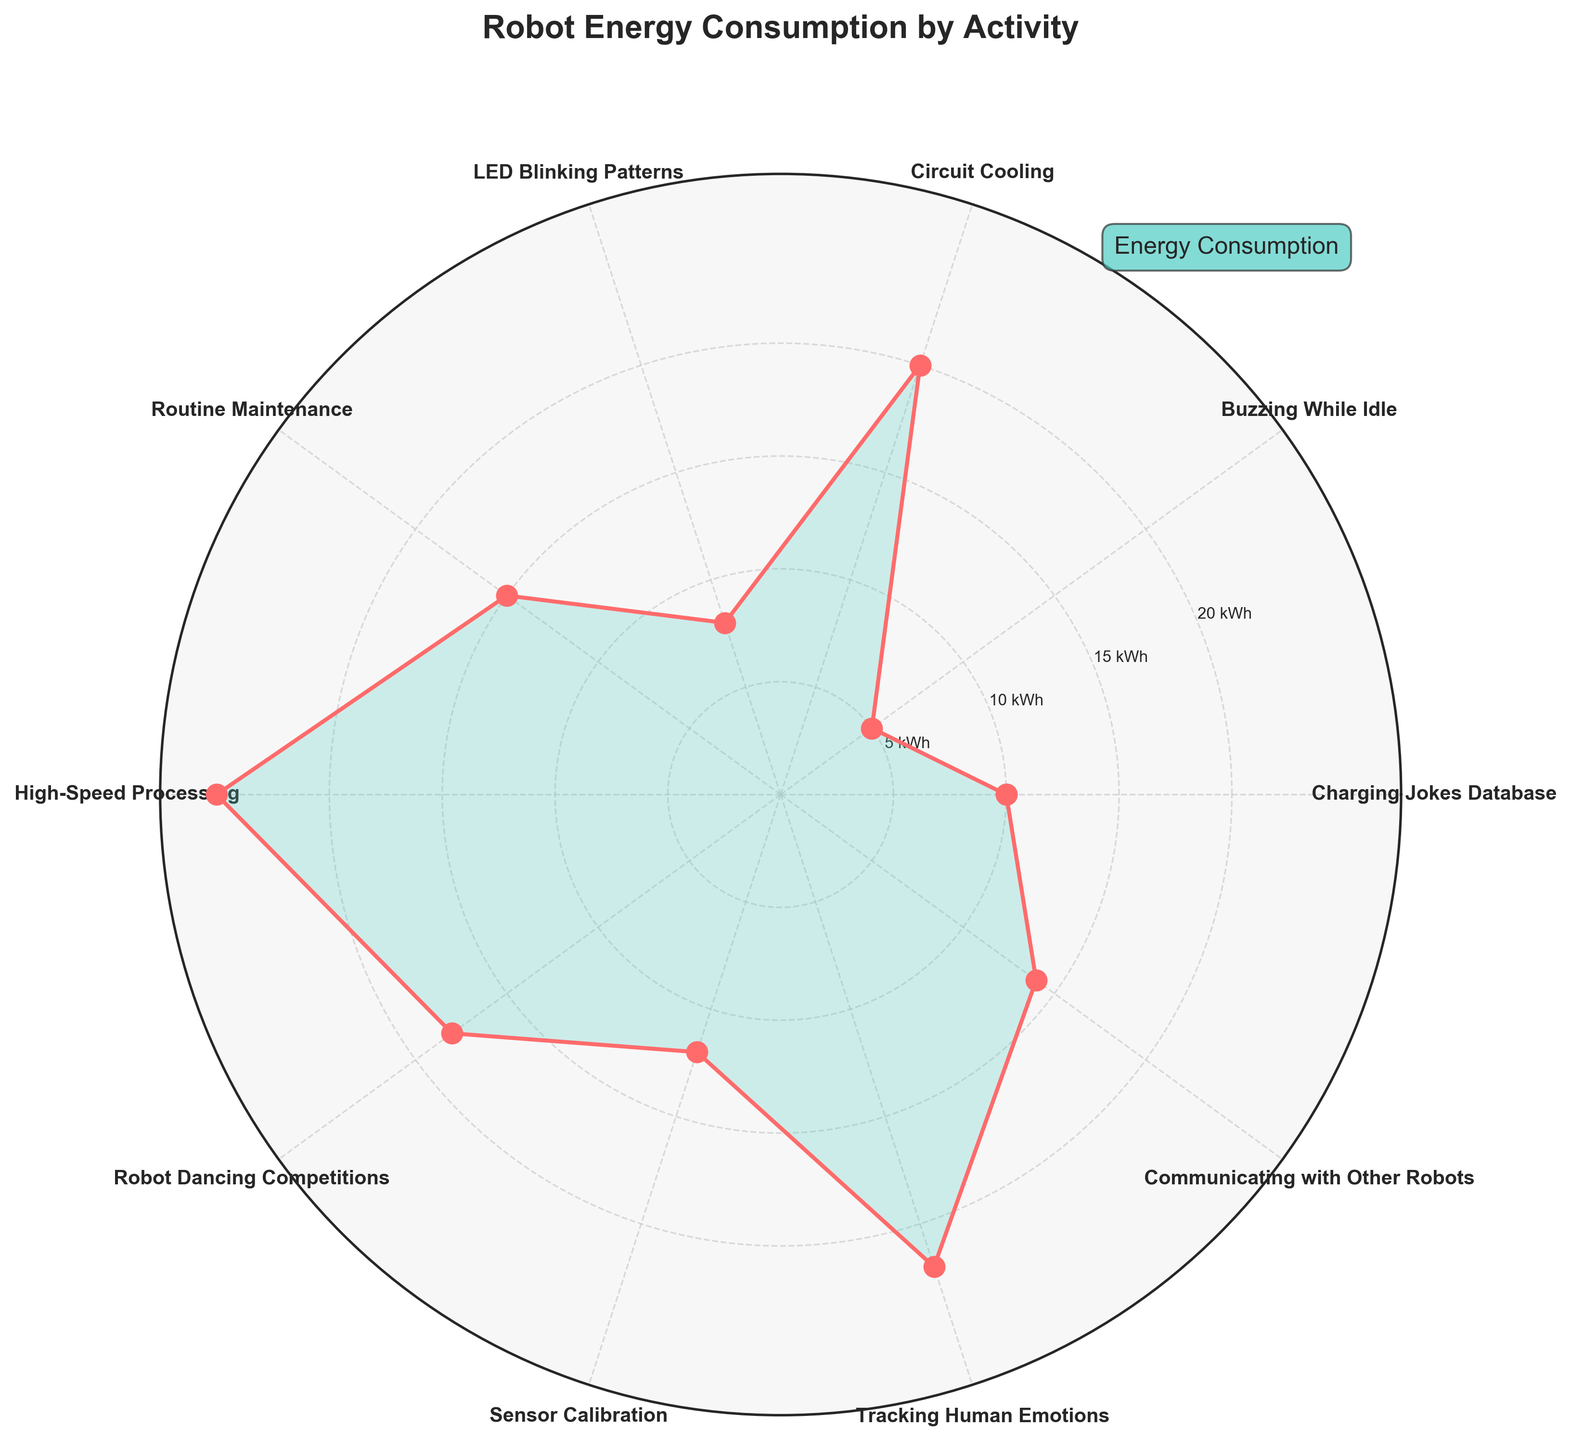What's the title of the figure? The title is positioned at the top of the plot, styled in a large, bold font for emphasis. It clearly indicates the main subject of the visualization.
Answer: Robot Energy Consumption by Activity How many activities are displayed in the chart? The chart displays each activity as a segment. By counting the number of unique labels around the plot, we can determine the number of activities.
Answer: 10 Which activity consumes the most energy? The activity with the highest point (furthest from the center) on the plot represents the maximum energy consumption. The extents of the radial lines indicate the energy levels for each activity.
Answer: High-Speed Processing What is the total energy consumption for Charging Jokes Database and LED Blinking Patterns combined? Locate the energy consumption values for Charging Jokes Database and LED Blinking Patterns on the plot. Their values are 10 kWh and 8 kWh respectively. Summing these gives 10 + 8 = 18 kWh.
Answer: 18 kWh Which activity consumes more energy: Robot Dancing Competitions or Communicating with Other Robots? Compare the radial length of the points for Robot Dancing Competitions and Communicating with Other Robots. The longer radial line represents higher energy consumption.
Answer: Robot Dancing Competitions What is the range of energy consumption values shown in the figure? Identify the smallest and largest energy values from the plot. The smallest value is 5 kWh, and the largest is 25 kWh. The range is 25 - 5 = 20 kWh.
Answer: 20 kWh Which activity has an energy consumption closest to the median activity energy consumption? List the energy values, order them, and find the middle value (median). The values: 5, 8, 10, 12, 14, 15, 18, 20, 22, 25. The median is between 15 and 18, closest to Routine Maintenance at 15 kWh.
Answer: Routine Maintenance How does Sensor Calibration's energy consumption compare to Circuit Cooling's? Identify the points corresponding to Sensor Calibration and Circuit Cooling. Compare the radial distances. Sensor Calibration consumes less energy (12 kWh) than Circuit Cooling (20 kWh).
Answer: Less What is the average energy consumption across all activities? Sum all energy consumption values and divide by the number of activities. (10 + 5 + 20 + 8 + 15 + 25 + 18 + 12 + 22 + 14)/10. This equals 149/10 = 14.9 kWh.
Answer: 14.9 kWh Which activities consume more energy than Tracking Human Emotions? Compare the radial positions for Tracking Human Emotions (22 kWh) with all other activities. Only High-Speed Processing (25 kWh) consumes more.
Answer: High-Speed Processing 